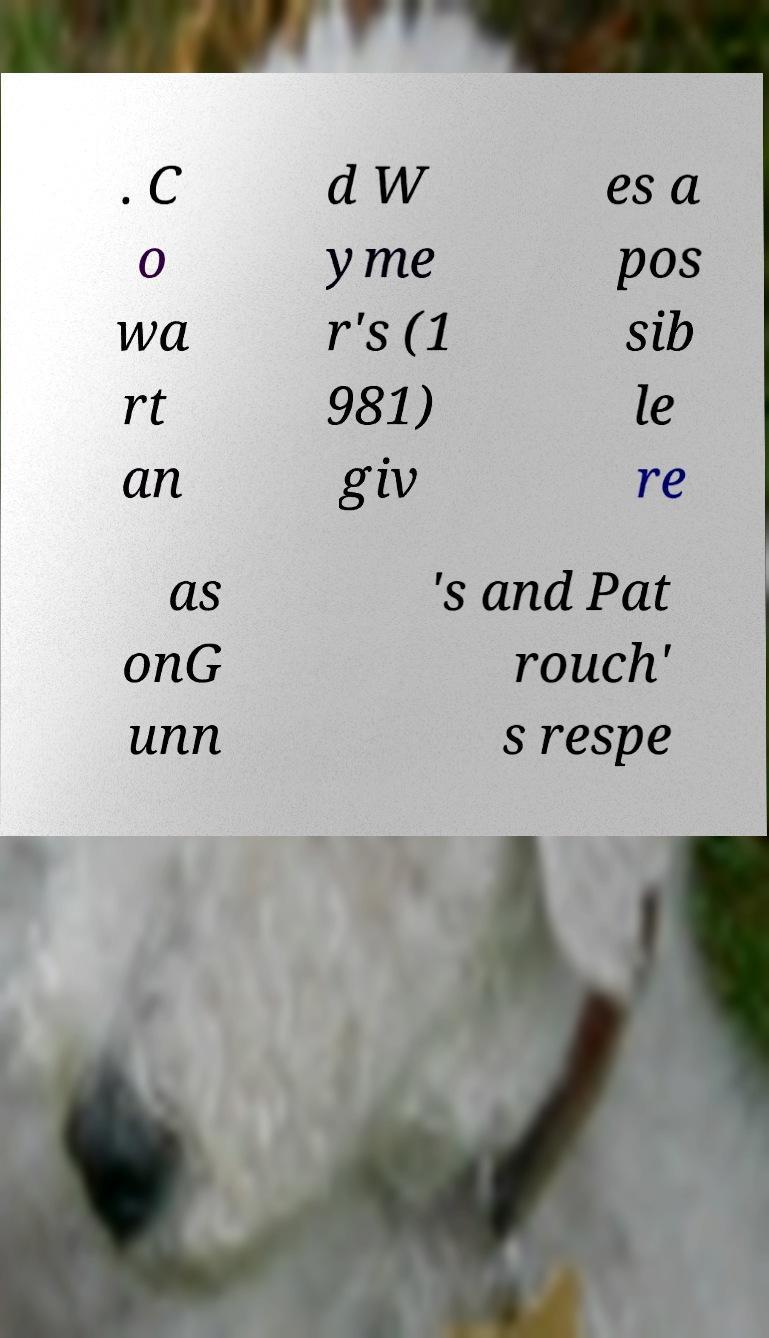There's text embedded in this image that I need extracted. Can you transcribe it verbatim? . C o wa rt an d W yme r's (1 981) giv es a pos sib le re as onG unn 's and Pat rouch' s respe 